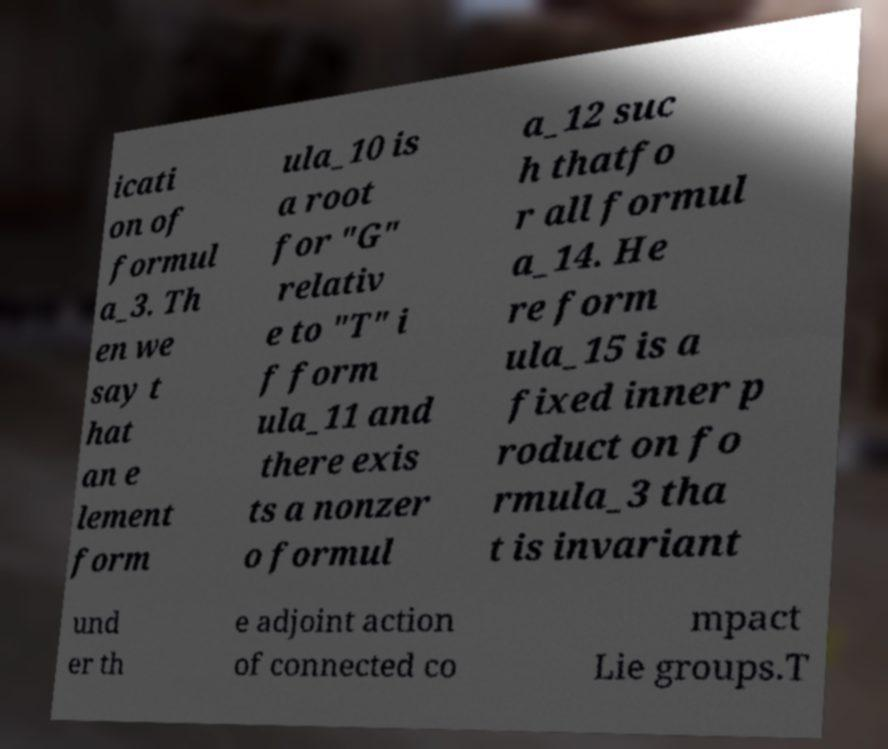Could you assist in decoding the text presented in this image and type it out clearly? icati on of formul a_3. Th en we say t hat an e lement form ula_10 is a root for "G" relativ e to "T" i f form ula_11 and there exis ts a nonzer o formul a_12 suc h thatfo r all formul a_14. He re form ula_15 is a fixed inner p roduct on fo rmula_3 tha t is invariant und er th e adjoint action of connected co mpact Lie groups.T 